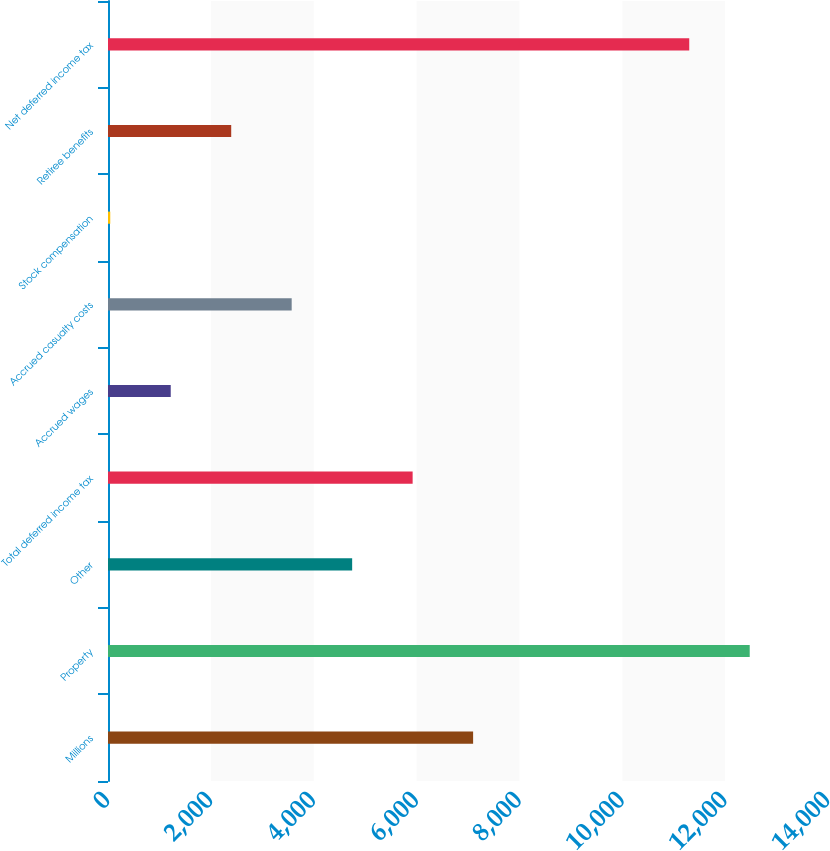<chart> <loc_0><loc_0><loc_500><loc_500><bar_chart><fcel>Millions<fcel>Property<fcel>Other<fcel>Total deferred income tax<fcel>Accrued wages<fcel>Accrued casualty costs<fcel>Stock compensation<fcel>Retiree benefits<fcel>Net deferred income tax<nl><fcel>7099.4<fcel>12477.9<fcel>4747.6<fcel>5923.5<fcel>1219.9<fcel>3571.7<fcel>44<fcel>2395.8<fcel>11302<nl></chart> 